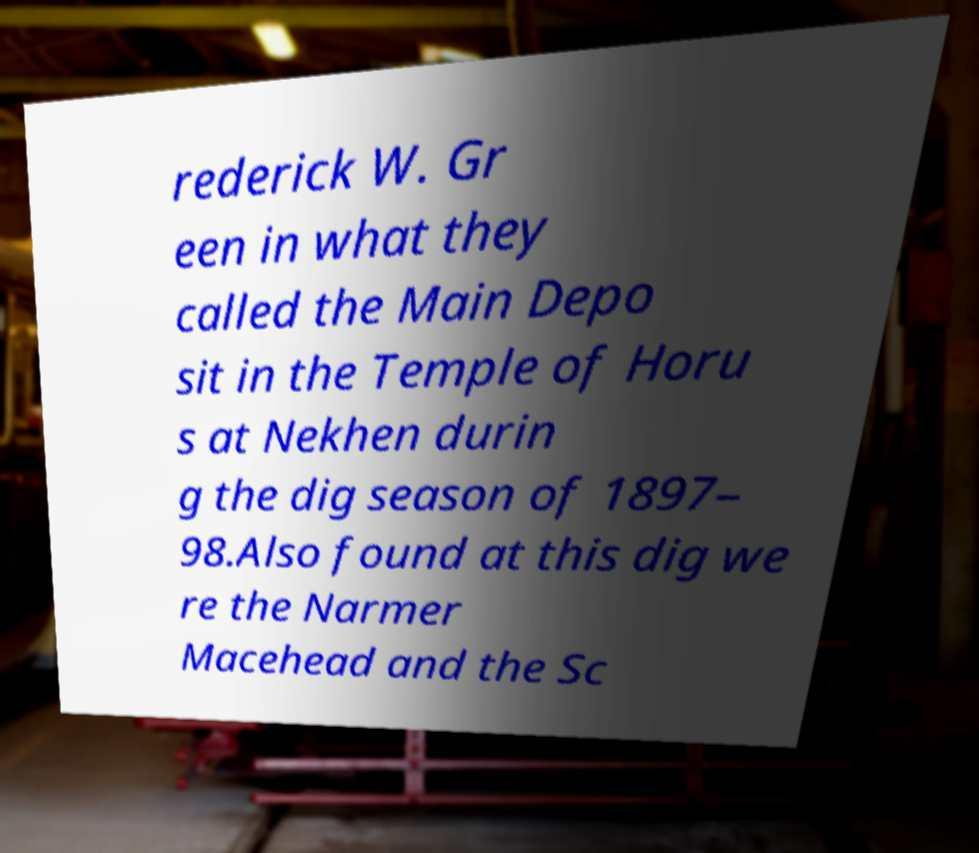Please identify and transcribe the text found in this image. rederick W. Gr een in what they called the Main Depo sit in the Temple of Horu s at Nekhen durin g the dig season of 1897– 98.Also found at this dig we re the Narmer Macehead and the Sc 